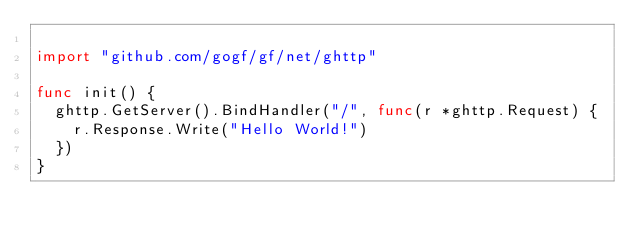<code> <loc_0><loc_0><loc_500><loc_500><_Go_>
import "github.com/gogf/gf/net/ghttp"

func init() {
	ghttp.GetServer().BindHandler("/", func(r *ghttp.Request) {
		r.Response.Write("Hello World!")
	})
}
</code> 